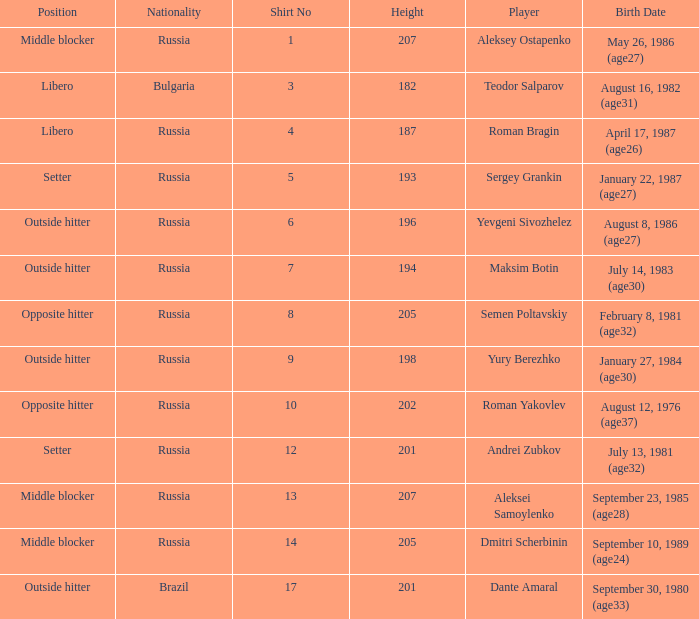What is Maksim Botin's position?  Outside hitter. 